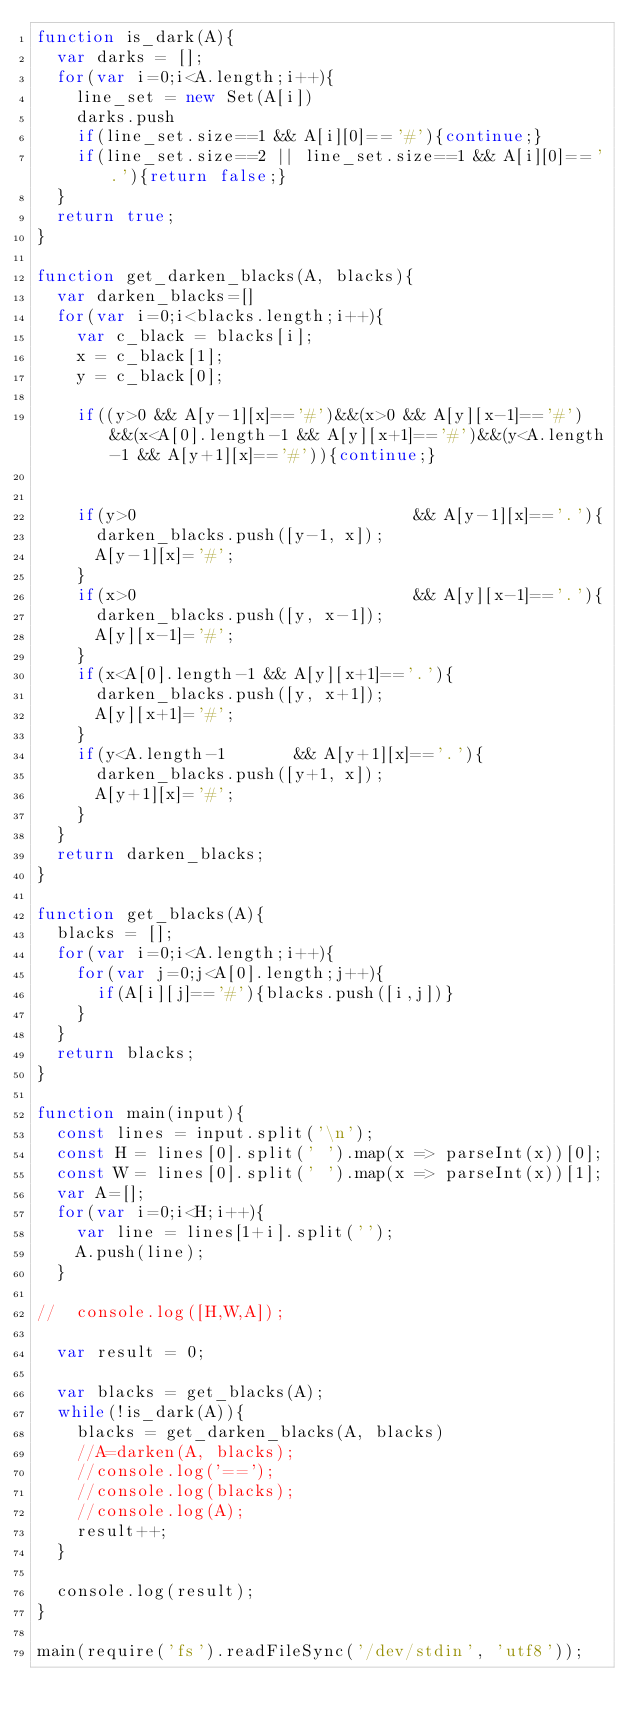<code> <loc_0><loc_0><loc_500><loc_500><_JavaScript_>function is_dark(A){
  var darks = [];
  for(var i=0;i<A.length;i++){
    line_set = new Set(A[i])
    darks.push
    if(line_set.size==1 && A[i][0]=='#'){continue;}
    if(line_set.size==2 || line_set.size==1 && A[i][0]=='.'){return false;}
  }
  return true;
}

function get_darken_blacks(A, blacks){
  var darken_blacks=[]
  for(var i=0;i<blacks.length;i++){
    var c_black = blacks[i];
    x = c_black[1];
    y = c_black[0];

    if((y>0 && A[y-1][x]=='#')&&(x>0 && A[y][x-1]=='#')&&(x<A[0].length-1 && A[y][x+1]=='#')&&(y<A.length-1 && A[y+1][x]=='#')){continue;}


    if(y>0                            && A[y-1][x]=='.'){
      darken_blacks.push([y-1, x]);
      A[y-1][x]='#';
    }
    if(x>0                            && A[y][x-1]=='.'){
      darken_blacks.push([y, x-1]);
      A[y][x-1]='#';
    }
    if(x<A[0].length-1 && A[y][x+1]=='.'){
      darken_blacks.push([y, x+1]);
      A[y][x+1]='#';
    }
    if(y<A.length-1       && A[y+1][x]=='.'){
      darken_blacks.push([y+1, x]);
      A[y+1][x]='#';
    }
  }
  return darken_blacks;
}

function get_blacks(A){
  blacks = [];
  for(var i=0;i<A.length;i++){
    for(var j=0;j<A[0].length;j++){
      if(A[i][j]=='#'){blacks.push([i,j])}
    }
  }
  return blacks;
}

function main(input){
  const lines = input.split('\n');
  const H = lines[0].split(' ').map(x => parseInt(x))[0];
  const W = lines[0].split(' ').map(x => parseInt(x))[1];
  var A=[];
  for(var i=0;i<H;i++){
    var line = lines[1+i].split('');
    A.push(line);
  }

//  console.log([H,W,A]);

  var result = 0;

  var blacks = get_blacks(A);
  while(!is_dark(A)){
    blacks = get_darken_blacks(A, blacks)
    //A=darken(A, blacks);
    //console.log('==');
    //console.log(blacks);
    //console.log(A);
    result++;
  }

  console.log(result);
}

main(require('fs').readFileSync('/dev/stdin', 'utf8'));
</code> 